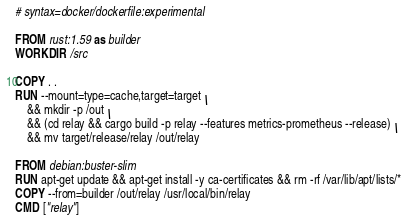Convert code to text. <code><loc_0><loc_0><loc_500><loc_500><_Dockerfile_># syntax=docker/dockerfile:experimental

FROM rust:1.59 as builder
WORKDIR /src

COPY . .
RUN --mount=type=cache,target=target \
    && mkdir -p /out \
    && (cd relay && cargo build -p relay --features metrics-prometheus --release) \
    && mv target/release/relay /out/relay

FROM debian:buster-slim
RUN apt-get update && apt-get install -y ca-certificates && rm -rf /var/lib/apt/lists/*
COPY --from=builder /out/relay /usr/local/bin/relay
CMD ["relay"]
</code> 